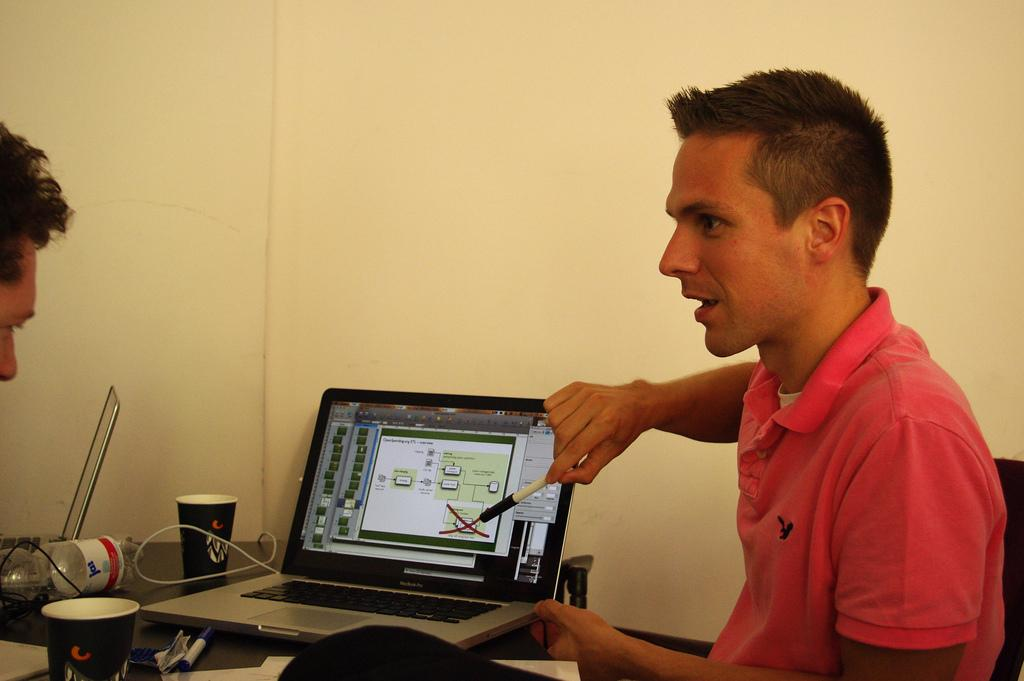How many people are present in the image? There are two persons in the image. What objects are on the table in the image? There are laptops, cups, and a bottle on the table. Can you describe any other items on the table? There are other unspecified things on the table. What type of yam is being used as a paperweight on the table? There is no yam present in the image, and therefore no such object is being used as a paperweight. 